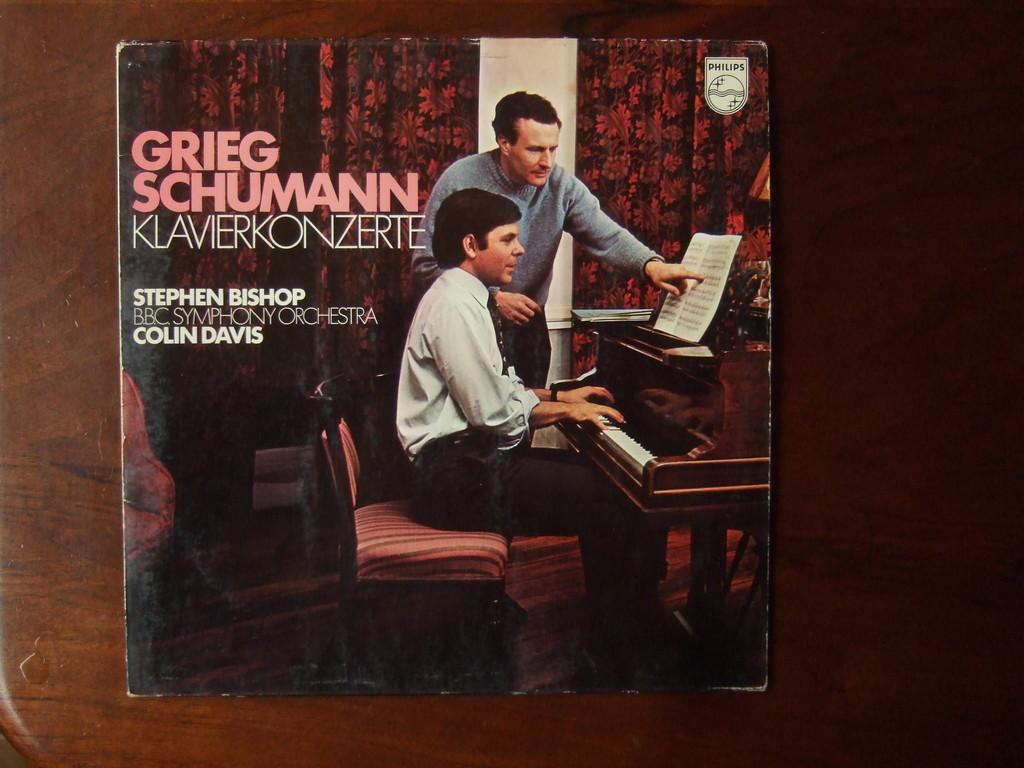What is the main subject of the magazine cover? The main subject of the magazine cover is a man playing piano. What additional information is included on the cover? The cover pic includes cm and altitude. Can you describe the man's actions in the image? There is a man standing in the image, and he is showing a book in front of him. What type of ocean can be seen in the background of the image? There is no ocean visible in the image; it features a man playing piano and showing a book. What kind of beast is present in the image? There is no beast present in the image. 